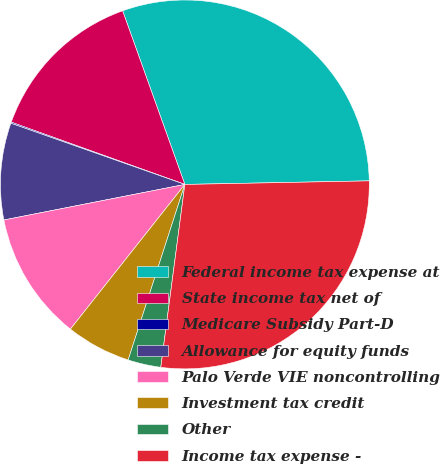<chart> <loc_0><loc_0><loc_500><loc_500><pie_chart><fcel>Federal income tax expense at<fcel>State income tax net of<fcel>Medicare Subsidy Part-D<fcel>Allowance for equity funds<fcel>Palo Verde VIE noncontrolling<fcel>Investment tax credit<fcel>Other<fcel>Income tax expense -<nl><fcel>30.17%<fcel>14.04%<fcel>0.1%<fcel>8.47%<fcel>11.26%<fcel>5.68%<fcel>2.89%<fcel>27.39%<nl></chart> 